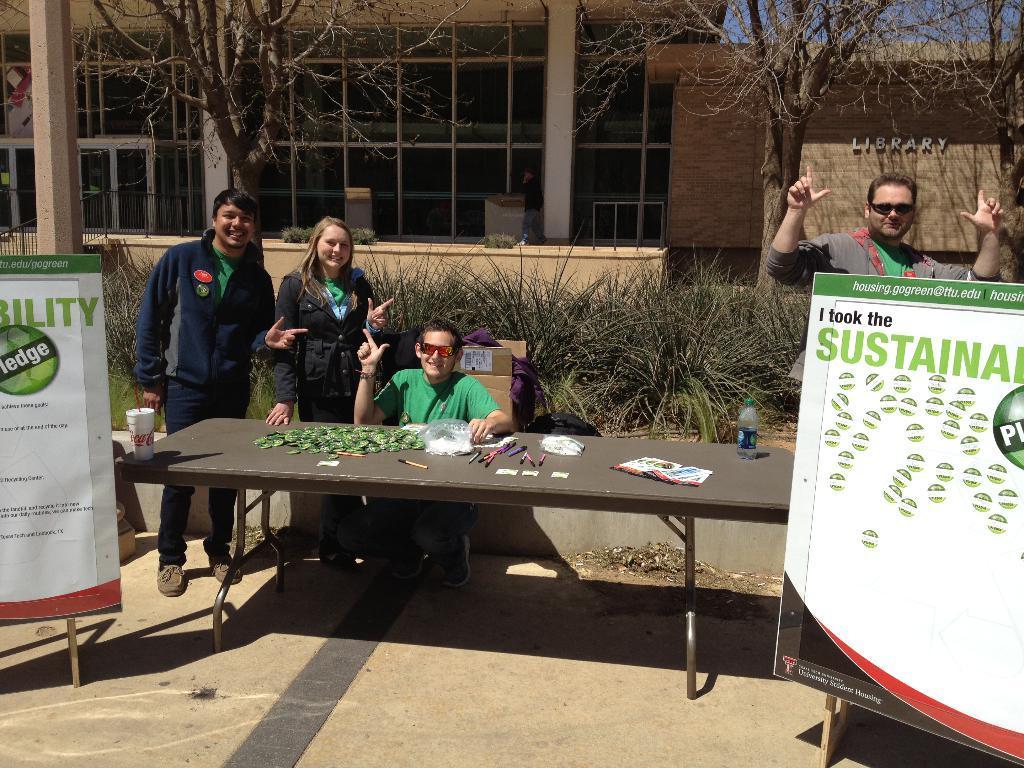How would you summarize this image in a sentence or two? In this image i can see inside view of a building and there are the two persons standing on the left side and in front of the building there are some trees and grass on the floor and there is a table ,on the table there are some objects kept on the table ,in front the table a person wearing wearing a green color shirt and wearing a spectacles. on the right side there is a hoarding board visible ,back side of hoarding board there is a person stand on the floor. 